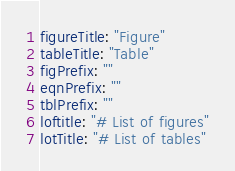Convert code to text. <code><loc_0><loc_0><loc_500><loc_500><_YAML_>figureTitle: "Figure"
tableTitle: "Table"
figPrefix: ""
eqnPrefix: ""
tblPrefix: ""
loftitle: "# List of figures"
lotTitle: "# List of tables"
</code> 